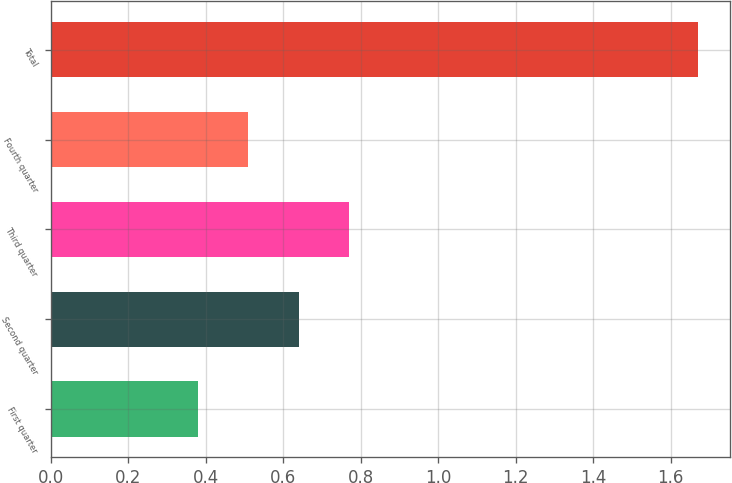Convert chart to OTSL. <chart><loc_0><loc_0><loc_500><loc_500><bar_chart><fcel>First quarter<fcel>Second quarter<fcel>Third quarter<fcel>Fourth quarter<fcel>Total<nl><fcel>0.38<fcel>0.64<fcel>0.77<fcel>0.51<fcel>1.67<nl></chart> 